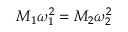<formula> <loc_0><loc_0><loc_500><loc_500>M _ { 1 } \omega _ { 1 } ^ { 2 } = M _ { 2 } \omega _ { 2 } ^ { 2 }</formula> 